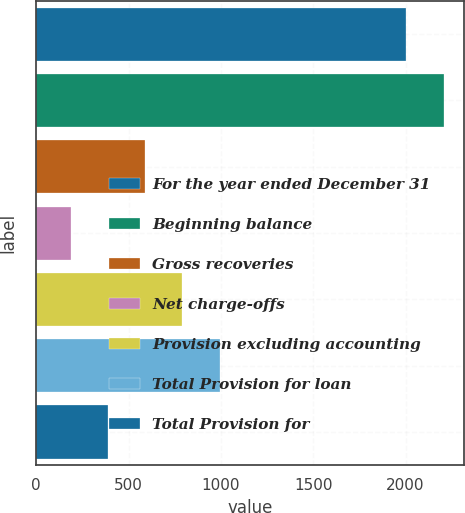Convert chart to OTSL. <chart><loc_0><loc_0><loc_500><loc_500><bar_chart><fcel>For the year ended December 31<fcel>Beginning balance<fcel>Gross recoveries<fcel>Net charge-offs<fcel>Provision excluding accounting<fcel>Total Provision for loan<fcel>Total Provision for<nl><fcel>2004<fcel>2205.8<fcel>589.6<fcel>186<fcel>791.4<fcel>993.2<fcel>387.8<nl></chart> 